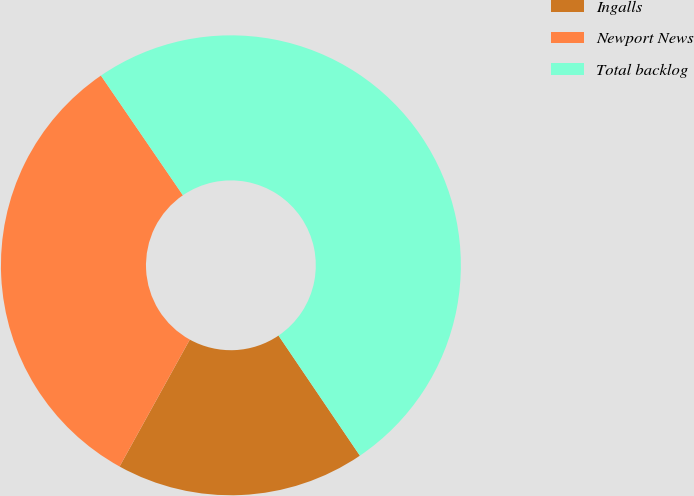Convert chart to OTSL. <chart><loc_0><loc_0><loc_500><loc_500><pie_chart><fcel>Ingalls<fcel>Newport News<fcel>Total backlog<nl><fcel>17.52%<fcel>32.4%<fcel>50.08%<nl></chart> 